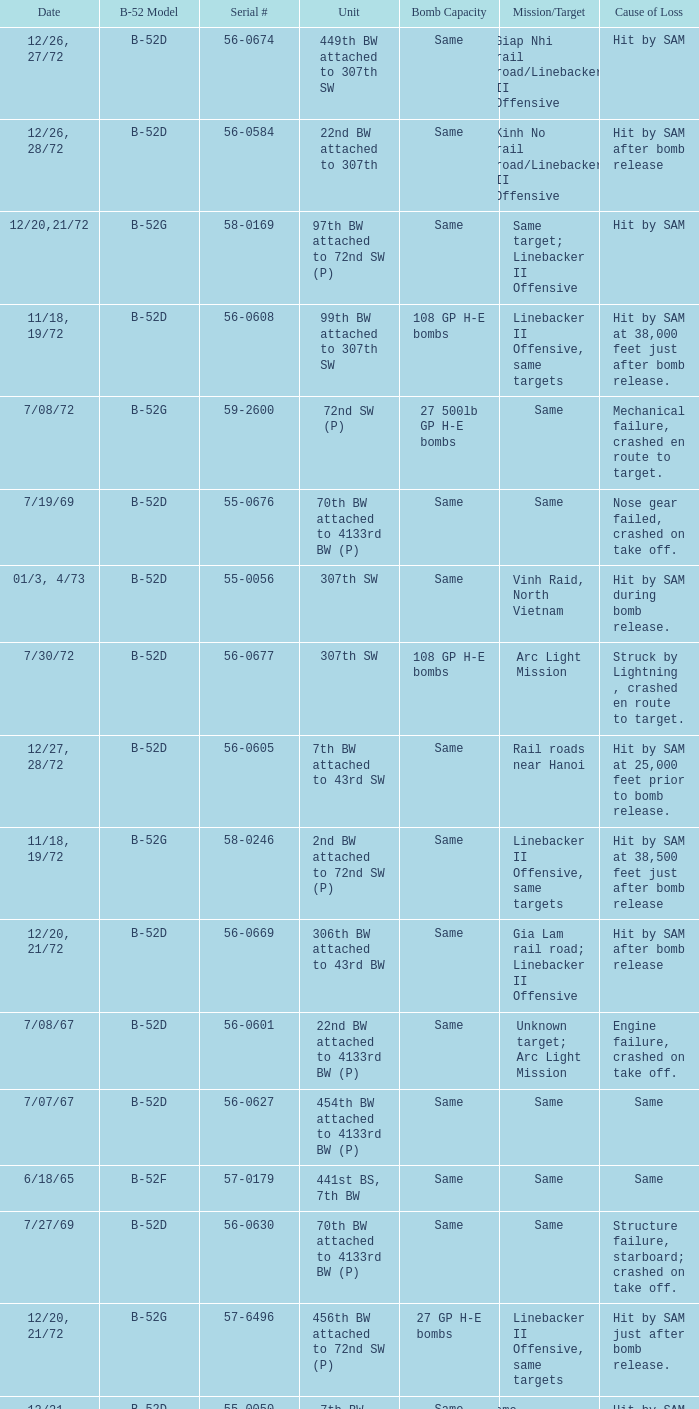When  same target; linebacker ii offensive is the same target what is the unit? 97th BW attached to 72nd SW (P). 